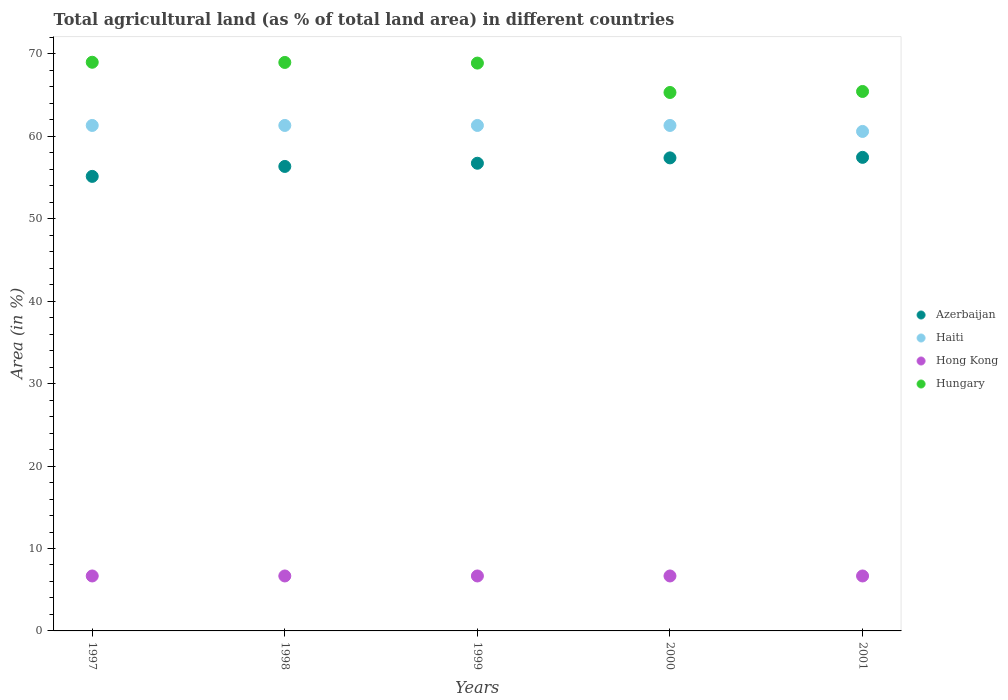What is the percentage of agricultural land in Haiti in 1998?
Make the answer very short. 61.32. Across all years, what is the maximum percentage of agricultural land in Hong Kong?
Provide a succinct answer. 6.67. Across all years, what is the minimum percentage of agricultural land in Azerbaijan?
Your answer should be compact. 55.14. In which year was the percentage of agricultural land in Hungary maximum?
Provide a succinct answer. 1997. In which year was the percentage of agricultural land in Haiti minimum?
Your answer should be compact. 2001. What is the total percentage of agricultural land in Hong Kong in the graph?
Provide a succinct answer. 33.33. What is the difference between the percentage of agricultural land in Haiti in 1999 and that in 2001?
Offer a terse response. 0.73. What is the difference between the percentage of agricultural land in Haiti in 1998 and the percentage of agricultural land in Hong Kong in 1999?
Offer a terse response. 54.65. What is the average percentage of agricultural land in Haiti per year?
Give a very brief answer. 61.18. In the year 2001, what is the difference between the percentage of agricultural land in Azerbaijan and percentage of agricultural land in Hong Kong?
Make the answer very short. 50.78. In how many years, is the percentage of agricultural land in Azerbaijan greater than 68 %?
Offer a terse response. 0. What is the ratio of the percentage of agricultural land in Hong Kong in 1998 to that in 2001?
Offer a terse response. 1. Is the percentage of agricultural land in Azerbaijan in 1997 less than that in 2001?
Offer a very short reply. Yes. Is the difference between the percentage of agricultural land in Azerbaijan in 1997 and 1999 greater than the difference between the percentage of agricultural land in Hong Kong in 1997 and 1999?
Your answer should be compact. No. What is the difference between the highest and the lowest percentage of agricultural land in Hungary?
Make the answer very short. 3.67. Is the sum of the percentage of agricultural land in Hungary in 1998 and 2001 greater than the maximum percentage of agricultural land in Azerbaijan across all years?
Your answer should be very brief. Yes. Is it the case that in every year, the sum of the percentage of agricultural land in Azerbaijan and percentage of agricultural land in Hong Kong  is greater than the sum of percentage of agricultural land in Hungary and percentage of agricultural land in Haiti?
Your answer should be compact. Yes. Is it the case that in every year, the sum of the percentage of agricultural land in Azerbaijan and percentage of agricultural land in Hungary  is greater than the percentage of agricultural land in Haiti?
Provide a succinct answer. Yes. Is the percentage of agricultural land in Haiti strictly less than the percentage of agricultural land in Azerbaijan over the years?
Provide a succinct answer. No. How many dotlines are there?
Give a very brief answer. 4. How many years are there in the graph?
Your answer should be very brief. 5. Are the values on the major ticks of Y-axis written in scientific E-notation?
Make the answer very short. No. How many legend labels are there?
Your response must be concise. 4. How are the legend labels stacked?
Your response must be concise. Vertical. What is the title of the graph?
Your answer should be very brief. Total agricultural land (as % of total land area) in different countries. What is the label or title of the X-axis?
Provide a succinct answer. Years. What is the label or title of the Y-axis?
Provide a short and direct response. Area (in %). What is the Area (in %) in Azerbaijan in 1997?
Offer a very short reply. 55.14. What is the Area (in %) in Haiti in 1997?
Keep it short and to the point. 61.32. What is the Area (in %) in Hong Kong in 1997?
Your response must be concise. 6.67. What is the Area (in %) of Hungary in 1997?
Your answer should be compact. 68.99. What is the Area (in %) in Azerbaijan in 1998?
Your answer should be very brief. 56.35. What is the Area (in %) in Haiti in 1998?
Make the answer very short. 61.32. What is the Area (in %) of Hong Kong in 1998?
Offer a terse response. 6.67. What is the Area (in %) in Hungary in 1998?
Make the answer very short. 68.96. What is the Area (in %) in Azerbaijan in 1999?
Your response must be concise. 56.74. What is the Area (in %) in Haiti in 1999?
Provide a succinct answer. 61.32. What is the Area (in %) of Hong Kong in 1999?
Your answer should be very brief. 6.67. What is the Area (in %) of Hungary in 1999?
Make the answer very short. 68.89. What is the Area (in %) of Azerbaijan in 2000?
Offer a very short reply. 57.39. What is the Area (in %) of Haiti in 2000?
Offer a very short reply. 61.32. What is the Area (in %) in Hong Kong in 2000?
Offer a very short reply. 6.67. What is the Area (in %) in Hungary in 2000?
Offer a very short reply. 65.32. What is the Area (in %) of Azerbaijan in 2001?
Offer a very short reply. 57.45. What is the Area (in %) of Haiti in 2001?
Offer a terse response. 60.6. What is the Area (in %) in Hong Kong in 2001?
Your response must be concise. 6.67. What is the Area (in %) of Hungary in 2001?
Your answer should be compact. 65.44. Across all years, what is the maximum Area (in %) in Azerbaijan?
Give a very brief answer. 57.45. Across all years, what is the maximum Area (in %) in Haiti?
Offer a very short reply. 61.32. Across all years, what is the maximum Area (in %) in Hong Kong?
Provide a short and direct response. 6.67. Across all years, what is the maximum Area (in %) in Hungary?
Provide a succinct answer. 68.99. Across all years, what is the minimum Area (in %) of Azerbaijan?
Your answer should be very brief. 55.14. Across all years, what is the minimum Area (in %) of Haiti?
Offer a terse response. 60.6. Across all years, what is the minimum Area (in %) in Hong Kong?
Provide a succinct answer. 6.67. Across all years, what is the minimum Area (in %) of Hungary?
Keep it short and to the point. 65.32. What is the total Area (in %) of Azerbaijan in the graph?
Provide a succinct answer. 283.06. What is the total Area (in %) in Haiti in the graph?
Your answer should be compact. 305.88. What is the total Area (in %) of Hong Kong in the graph?
Offer a terse response. 33.33. What is the total Area (in %) in Hungary in the graph?
Ensure brevity in your answer.  337.6. What is the difference between the Area (in %) in Azerbaijan in 1997 and that in 1998?
Make the answer very short. -1.21. What is the difference between the Area (in %) of Hong Kong in 1997 and that in 1998?
Offer a terse response. 0. What is the difference between the Area (in %) of Hungary in 1997 and that in 1998?
Offer a very short reply. 0.02. What is the difference between the Area (in %) in Azerbaijan in 1997 and that in 1999?
Make the answer very short. -1.6. What is the difference between the Area (in %) in Hong Kong in 1997 and that in 1999?
Make the answer very short. 0. What is the difference between the Area (in %) of Hungary in 1997 and that in 1999?
Provide a short and direct response. 0.1. What is the difference between the Area (in %) in Azerbaijan in 1997 and that in 2000?
Offer a terse response. -2.25. What is the difference between the Area (in %) of Hungary in 1997 and that in 2000?
Provide a short and direct response. 3.67. What is the difference between the Area (in %) of Azerbaijan in 1997 and that in 2001?
Your response must be concise. -2.31. What is the difference between the Area (in %) of Haiti in 1997 and that in 2001?
Make the answer very short. 0.73. What is the difference between the Area (in %) of Hong Kong in 1997 and that in 2001?
Your answer should be very brief. 0. What is the difference between the Area (in %) in Hungary in 1997 and that in 2001?
Your response must be concise. 3.54. What is the difference between the Area (in %) in Azerbaijan in 1998 and that in 1999?
Make the answer very short. -0.39. What is the difference between the Area (in %) in Hungary in 1998 and that in 1999?
Provide a short and direct response. 0.08. What is the difference between the Area (in %) in Azerbaijan in 1998 and that in 2000?
Your answer should be very brief. -1.04. What is the difference between the Area (in %) in Hong Kong in 1998 and that in 2000?
Keep it short and to the point. 0. What is the difference between the Area (in %) in Hungary in 1998 and that in 2000?
Offer a very short reply. 3.64. What is the difference between the Area (in %) in Azerbaijan in 1998 and that in 2001?
Your answer should be very brief. -1.1. What is the difference between the Area (in %) of Haiti in 1998 and that in 2001?
Give a very brief answer. 0.73. What is the difference between the Area (in %) in Hong Kong in 1998 and that in 2001?
Provide a succinct answer. 0. What is the difference between the Area (in %) in Hungary in 1998 and that in 2001?
Your answer should be very brief. 3.52. What is the difference between the Area (in %) of Azerbaijan in 1999 and that in 2000?
Offer a very short reply. -0.65. What is the difference between the Area (in %) of Hong Kong in 1999 and that in 2000?
Provide a succinct answer. 0. What is the difference between the Area (in %) of Hungary in 1999 and that in 2000?
Ensure brevity in your answer.  3.57. What is the difference between the Area (in %) of Azerbaijan in 1999 and that in 2001?
Provide a succinct answer. -0.71. What is the difference between the Area (in %) in Haiti in 1999 and that in 2001?
Give a very brief answer. 0.73. What is the difference between the Area (in %) of Hungary in 1999 and that in 2001?
Ensure brevity in your answer.  3.44. What is the difference between the Area (in %) in Azerbaijan in 2000 and that in 2001?
Ensure brevity in your answer.  -0.06. What is the difference between the Area (in %) in Haiti in 2000 and that in 2001?
Provide a short and direct response. 0.73. What is the difference between the Area (in %) of Hong Kong in 2000 and that in 2001?
Keep it short and to the point. 0. What is the difference between the Area (in %) of Hungary in 2000 and that in 2001?
Your answer should be very brief. -0.12. What is the difference between the Area (in %) of Azerbaijan in 1997 and the Area (in %) of Haiti in 1998?
Provide a short and direct response. -6.18. What is the difference between the Area (in %) in Azerbaijan in 1997 and the Area (in %) in Hong Kong in 1998?
Your response must be concise. 48.47. What is the difference between the Area (in %) in Azerbaijan in 1997 and the Area (in %) in Hungary in 1998?
Ensure brevity in your answer.  -13.82. What is the difference between the Area (in %) in Haiti in 1997 and the Area (in %) in Hong Kong in 1998?
Offer a terse response. 54.65. What is the difference between the Area (in %) of Haiti in 1997 and the Area (in %) of Hungary in 1998?
Your answer should be compact. -7.64. What is the difference between the Area (in %) in Hong Kong in 1997 and the Area (in %) in Hungary in 1998?
Ensure brevity in your answer.  -62.3. What is the difference between the Area (in %) in Azerbaijan in 1997 and the Area (in %) in Haiti in 1999?
Your answer should be compact. -6.18. What is the difference between the Area (in %) of Azerbaijan in 1997 and the Area (in %) of Hong Kong in 1999?
Your answer should be very brief. 48.47. What is the difference between the Area (in %) in Azerbaijan in 1997 and the Area (in %) in Hungary in 1999?
Your response must be concise. -13.74. What is the difference between the Area (in %) in Haiti in 1997 and the Area (in %) in Hong Kong in 1999?
Keep it short and to the point. 54.65. What is the difference between the Area (in %) of Haiti in 1997 and the Area (in %) of Hungary in 1999?
Give a very brief answer. -7.57. What is the difference between the Area (in %) of Hong Kong in 1997 and the Area (in %) of Hungary in 1999?
Provide a succinct answer. -62.22. What is the difference between the Area (in %) in Azerbaijan in 1997 and the Area (in %) in Haiti in 2000?
Make the answer very short. -6.18. What is the difference between the Area (in %) of Azerbaijan in 1997 and the Area (in %) of Hong Kong in 2000?
Keep it short and to the point. 48.47. What is the difference between the Area (in %) of Azerbaijan in 1997 and the Area (in %) of Hungary in 2000?
Your answer should be very brief. -10.18. What is the difference between the Area (in %) in Haiti in 1997 and the Area (in %) in Hong Kong in 2000?
Offer a very short reply. 54.65. What is the difference between the Area (in %) in Haiti in 1997 and the Area (in %) in Hungary in 2000?
Your answer should be very brief. -4. What is the difference between the Area (in %) in Hong Kong in 1997 and the Area (in %) in Hungary in 2000?
Ensure brevity in your answer.  -58.65. What is the difference between the Area (in %) in Azerbaijan in 1997 and the Area (in %) in Haiti in 2001?
Keep it short and to the point. -5.45. What is the difference between the Area (in %) in Azerbaijan in 1997 and the Area (in %) in Hong Kong in 2001?
Your answer should be compact. 48.47. What is the difference between the Area (in %) in Azerbaijan in 1997 and the Area (in %) in Hungary in 2001?
Ensure brevity in your answer.  -10.3. What is the difference between the Area (in %) in Haiti in 1997 and the Area (in %) in Hong Kong in 2001?
Make the answer very short. 54.65. What is the difference between the Area (in %) of Haiti in 1997 and the Area (in %) of Hungary in 2001?
Your answer should be compact. -4.12. What is the difference between the Area (in %) in Hong Kong in 1997 and the Area (in %) in Hungary in 2001?
Your answer should be very brief. -58.78. What is the difference between the Area (in %) in Azerbaijan in 1998 and the Area (in %) in Haiti in 1999?
Ensure brevity in your answer.  -4.97. What is the difference between the Area (in %) of Azerbaijan in 1998 and the Area (in %) of Hong Kong in 1999?
Offer a very short reply. 49.68. What is the difference between the Area (in %) in Azerbaijan in 1998 and the Area (in %) in Hungary in 1999?
Provide a succinct answer. -12.54. What is the difference between the Area (in %) in Haiti in 1998 and the Area (in %) in Hong Kong in 1999?
Offer a terse response. 54.65. What is the difference between the Area (in %) in Haiti in 1998 and the Area (in %) in Hungary in 1999?
Provide a short and direct response. -7.57. What is the difference between the Area (in %) in Hong Kong in 1998 and the Area (in %) in Hungary in 1999?
Your answer should be very brief. -62.22. What is the difference between the Area (in %) in Azerbaijan in 1998 and the Area (in %) in Haiti in 2000?
Keep it short and to the point. -4.97. What is the difference between the Area (in %) in Azerbaijan in 1998 and the Area (in %) in Hong Kong in 2000?
Offer a terse response. 49.68. What is the difference between the Area (in %) in Azerbaijan in 1998 and the Area (in %) in Hungary in 2000?
Keep it short and to the point. -8.97. What is the difference between the Area (in %) of Haiti in 1998 and the Area (in %) of Hong Kong in 2000?
Keep it short and to the point. 54.65. What is the difference between the Area (in %) of Haiti in 1998 and the Area (in %) of Hungary in 2000?
Provide a succinct answer. -4. What is the difference between the Area (in %) in Hong Kong in 1998 and the Area (in %) in Hungary in 2000?
Your answer should be very brief. -58.65. What is the difference between the Area (in %) in Azerbaijan in 1998 and the Area (in %) in Haiti in 2001?
Make the answer very short. -4.25. What is the difference between the Area (in %) in Azerbaijan in 1998 and the Area (in %) in Hong Kong in 2001?
Offer a terse response. 49.68. What is the difference between the Area (in %) of Azerbaijan in 1998 and the Area (in %) of Hungary in 2001?
Provide a succinct answer. -9.09. What is the difference between the Area (in %) of Haiti in 1998 and the Area (in %) of Hong Kong in 2001?
Your answer should be compact. 54.65. What is the difference between the Area (in %) of Haiti in 1998 and the Area (in %) of Hungary in 2001?
Provide a short and direct response. -4.12. What is the difference between the Area (in %) of Hong Kong in 1998 and the Area (in %) of Hungary in 2001?
Ensure brevity in your answer.  -58.78. What is the difference between the Area (in %) in Azerbaijan in 1999 and the Area (in %) in Haiti in 2000?
Provide a succinct answer. -4.58. What is the difference between the Area (in %) in Azerbaijan in 1999 and the Area (in %) in Hong Kong in 2000?
Make the answer very short. 50.07. What is the difference between the Area (in %) of Azerbaijan in 1999 and the Area (in %) of Hungary in 2000?
Offer a very short reply. -8.58. What is the difference between the Area (in %) in Haiti in 1999 and the Area (in %) in Hong Kong in 2000?
Provide a short and direct response. 54.65. What is the difference between the Area (in %) in Haiti in 1999 and the Area (in %) in Hungary in 2000?
Make the answer very short. -4. What is the difference between the Area (in %) of Hong Kong in 1999 and the Area (in %) of Hungary in 2000?
Your answer should be very brief. -58.65. What is the difference between the Area (in %) in Azerbaijan in 1999 and the Area (in %) in Haiti in 2001?
Offer a terse response. -3.86. What is the difference between the Area (in %) in Azerbaijan in 1999 and the Area (in %) in Hong Kong in 2001?
Offer a terse response. 50.07. What is the difference between the Area (in %) in Azerbaijan in 1999 and the Area (in %) in Hungary in 2001?
Your answer should be very brief. -8.71. What is the difference between the Area (in %) in Haiti in 1999 and the Area (in %) in Hong Kong in 2001?
Give a very brief answer. 54.65. What is the difference between the Area (in %) of Haiti in 1999 and the Area (in %) of Hungary in 2001?
Offer a very short reply. -4.12. What is the difference between the Area (in %) in Hong Kong in 1999 and the Area (in %) in Hungary in 2001?
Give a very brief answer. -58.78. What is the difference between the Area (in %) in Azerbaijan in 2000 and the Area (in %) in Haiti in 2001?
Offer a terse response. -3.21. What is the difference between the Area (in %) of Azerbaijan in 2000 and the Area (in %) of Hong Kong in 2001?
Make the answer very short. 50.72. What is the difference between the Area (in %) in Azerbaijan in 2000 and the Area (in %) in Hungary in 2001?
Offer a terse response. -8.06. What is the difference between the Area (in %) in Haiti in 2000 and the Area (in %) in Hong Kong in 2001?
Provide a short and direct response. 54.65. What is the difference between the Area (in %) of Haiti in 2000 and the Area (in %) of Hungary in 2001?
Keep it short and to the point. -4.12. What is the difference between the Area (in %) in Hong Kong in 2000 and the Area (in %) in Hungary in 2001?
Offer a very short reply. -58.78. What is the average Area (in %) in Azerbaijan per year?
Make the answer very short. 56.61. What is the average Area (in %) in Haiti per year?
Ensure brevity in your answer.  61.18. What is the average Area (in %) of Hungary per year?
Offer a terse response. 67.52. In the year 1997, what is the difference between the Area (in %) of Azerbaijan and Area (in %) of Haiti?
Your response must be concise. -6.18. In the year 1997, what is the difference between the Area (in %) in Azerbaijan and Area (in %) in Hong Kong?
Your response must be concise. 48.47. In the year 1997, what is the difference between the Area (in %) in Azerbaijan and Area (in %) in Hungary?
Offer a very short reply. -13.85. In the year 1997, what is the difference between the Area (in %) of Haiti and Area (in %) of Hong Kong?
Ensure brevity in your answer.  54.65. In the year 1997, what is the difference between the Area (in %) in Haiti and Area (in %) in Hungary?
Your response must be concise. -7.67. In the year 1997, what is the difference between the Area (in %) of Hong Kong and Area (in %) of Hungary?
Make the answer very short. -62.32. In the year 1998, what is the difference between the Area (in %) in Azerbaijan and Area (in %) in Haiti?
Your answer should be very brief. -4.97. In the year 1998, what is the difference between the Area (in %) in Azerbaijan and Area (in %) in Hong Kong?
Offer a very short reply. 49.68. In the year 1998, what is the difference between the Area (in %) of Azerbaijan and Area (in %) of Hungary?
Your response must be concise. -12.62. In the year 1998, what is the difference between the Area (in %) in Haiti and Area (in %) in Hong Kong?
Make the answer very short. 54.65. In the year 1998, what is the difference between the Area (in %) of Haiti and Area (in %) of Hungary?
Your answer should be compact. -7.64. In the year 1998, what is the difference between the Area (in %) in Hong Kong and Area (in %) in Hungary?
Offer a terse response. -62.3. In the year 1999, what is the difference between the Area (in %) of Azerbaijan and Area (in %) of Haiti?
Provide a succinct answer. -4.58. In the year 1999, what is the difference between the Area (in %) of Azerbaijan and Area (in %) of Hong Kong?
Your answer should be very brief. 50.07. In the year 1999, what is the difference between the Area (in %) of Azerbaijan and Area (in %) of Hungary?
Ensure brevity in your answer.  -12.15. In the year 1999, what is the difference between the Area (in %) of Haiti and Area (in %) of Hong Kong?
Provide a succinct answer. 54.65. In the year 1999, what is the difference between the Area (in %) in Haiti and Area (in %) in Hungary?
Provide a succinct answer. -7.57. In the year 1999, what is the difference between the Area (in %) of Hong Kong and Area (in %) of Hungary?
Your response must be concise. -62.22. In the year 2000, what is the difference between the Area (in %) in Azerbaijan and Area (in %) in Haiti?
Offer a terse response. -3.93. In the year 2000, what is the difference between the Area (in %) in Azerbaijan and Area (in %) in Hong Kong?
Your answer should be compact. 50.72. In the year 2000, what is the difference between the Area (in %) in Azerbaijan and Area (in %) in Hungary?
Your response must be concise. -7.93. In the year 2000, what is the difference between the Area (in %) of Haiti and Area (in %) of Hong Kong?
Give a very brief answer. 54.65. In the year 2000, what is the difference between the Area (in %) of Haiti and Area (in %) of Hungary?
Offer a very short reply. -4. In the year 2000, what is the difference between the Area (in %) in Hong Kong and Area (in %) in Hungary?
Your answer should be compact. -58.65. In the year 2001, what is the difference between the Area (in %) in Azerbaijan and Area (in %) in Haiti?
Ensure brevity in your answer.  -3.15. In the year 2001, what is the difference between the Area (in %) in Azerbaijan and Area (in %) in Hong Kong?
Keep it short and to the point. 50.78. In the year 2001, what is the difference between the Area (in %) in Azerbaijan and Area (in %) in Hungary?
Give a very brief answer. -7.99. In the year 2001, what is the difference between the Area (in %) in Haiti and Area (in %) in Hong Kong?
Give a very brief answer. 53.93. In the year 2001, what is the difference between the Area (in %) of Haiti and Area (in %) of Hungary?
Provide a succinct answer. -4.85. In the year 2001, what is the difference between the Area (in %) of Hong Kong and Area (in %) of Hungary?
Your answer should be very brief. -58.78. What is the ratio of the Area (in %) in Azerbaijan in 1997 to that in 1998?
Keep it short and to the point. 0.98. What is the ratio of the Area (in %) in Azerbaijan in 1997 to that in 1999?
Your answer should be compact. 0.97. What is the ratio of the Area (in %) in Haiti in 1997 to that in 1999?
Ensure brevity in your answer.  1. What is the ratio of the Area (in %) of Hong Kong in 1997 to that in 1999?
Your answer should be compact. 1. What is the ratio of the Area (in %) in Hungary in 1997 to that in 1999?
Your answer should be very brief. 1. What is the ratio of the Area (in %) of Azerbaijan in 1997 to that in 2000?
Ensure brevity in your answer.  0.96. What is the ratio of the Area (in %) of Haiti in 1997 to that in 2000?
Your answer should be compact. 1. What is the ratio of the Area (in %) in Hungary in 1997 to that in 2000?
Give a very brief answer. 1.06. What is the ratio of the Area (in %) of Azerbaijan in 1997 to that in 2001?
Ensure brevity in your answer.  0.96. What is the ratio of the Area (in %) in Hong Kong in 1997 to that in 2001?
Offer a very short reply. 1. What is the ratio of the Area (in %) in Hungary in 1997 to that in 2001?
Your answer should be compact. 1.05. What is the ratio of the Area (in %) in Haiti in 1998 to that in 1999?
Provide a succinct answer. 1. What is the ratio of the Area (in %) of Hong Kong in 1998 to that in 1999?
Offer a very short reply. 1. What is the ratio of the Area (in %) of Azerbaijan in 1998 to that in 2000?
Ensure brevity in your answer.  0.98. What is the ratio of the Area (in %) in Haiti in 1998 to that in 2000?
Offer a terse response. 1. What is the ratio of the Area (in %) in Hong Kong in 1998 to that in 2000?
Offer a terse response. 1. What is the ratio of the Area (in %) of Hungary in 1998 to that in 2000?
Your answer should be very brief. 1.06. What is the ratio of the Area (in %) of Azerbaijan in 1998 to that in 2001?
Provide a succinct answer. 0.98. What is the ratio of the Area (in %) of Hungary in 1998 to that in 2001?
Your answer should be compact. 1.05. What is the ratio of the Area (in %) in Azerbaijan in 1999 to that in 2000?
Provide a succinct answer. 0.99. What is the ratio of the Area (in %) of Haiti in 1999 to that in 2000?
Offer a terse response. 1. What is the ratio of the Area (in %) of Hungary in 1999 to that in 2000?
Ensure brevity in your answer.  1.05. What is the ratio of the Area (in %) in Azerbaijan in 1999 to that in 2001?
Provide a succinct answer. 0.99. What is the ratio of the Area (in %) in Haiti in 1999 to that in 2001?
Keep it short and to the point. 1.01. What is the ratio of the Area (in %) in Hong Kong in 1999 to that in 2001?
Give a very brief answer. 1. What is the ratio of the Area (in %) in Hungary in 1999 to that in 2001?
Offer a terse response. 1.05. What is the ratio of the Area (in %) of Hungary in 2000 to that in 2001?
Provide a succinct answer. 1. What is the difference between the highest and the second highest Area (in %) of Azerbaijan?
Keep it short and to the point. 0.06. What is the difference between the highest and the second highest Area (in %) in Haiti?
Keep it short and to the point. 0. What is the difference between the highest and the second highest Area (in %) of Hong Kong?
Your answer should be very brief. 0. What is the difference between the highest and the second highest Area (in %) in Hungary?
Your answer should be very brief. 0.02. What is the difference between the highest and the lowest Area (in %) of Azerbaijan?
Your answer should be very brief. 2.31. What is the difference between the highest and the lowest Area (in %) in Haiti?
Provide a succinct answer. 0.73. What is the difference between the highest and the lowest Area (in %) of Hong Kong?
Make the answer very short. 0. What is the difference between the highest and the lowest Area (in %) of Hungary?
Offer a very short reply. 3.67. 